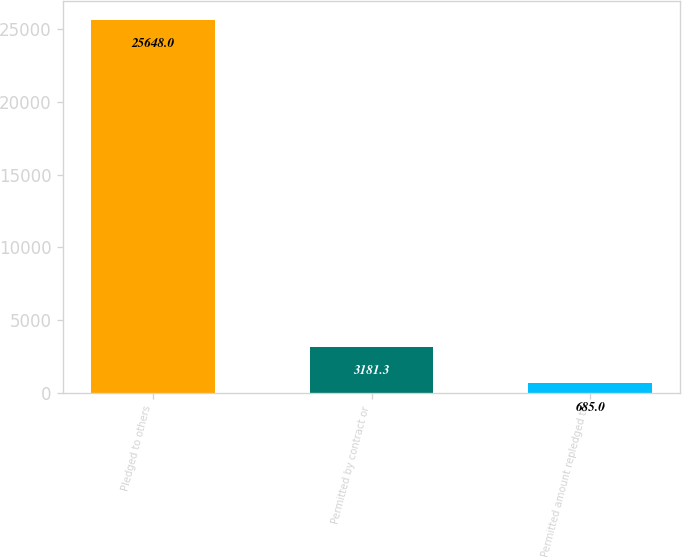<chart> <loc_0><loc_0><loc_500><loc_500><bar_chart><fcel>Pledged to others<fcel>Permitted by contract or<fcel>Permitted amount repledged to<nl><fcel>25648<fcel>3181.3<fcel>685<nl></chart> 